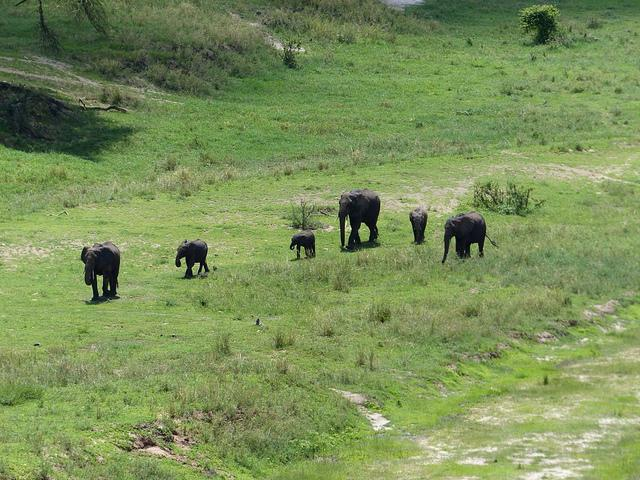Why might some of their trunks be curled? Please explain your reasoning. eating. The trunks are curled to eat. 